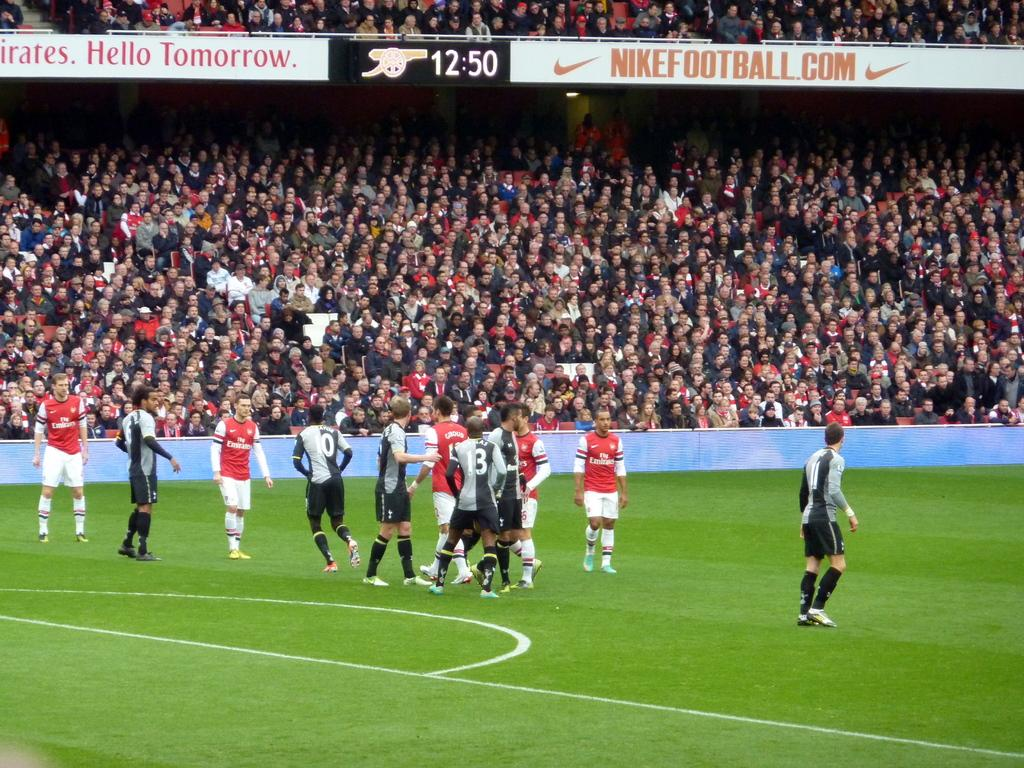<image>
Provide a brief description of the given image. the word tomorrow is on a sign above the soccer field 